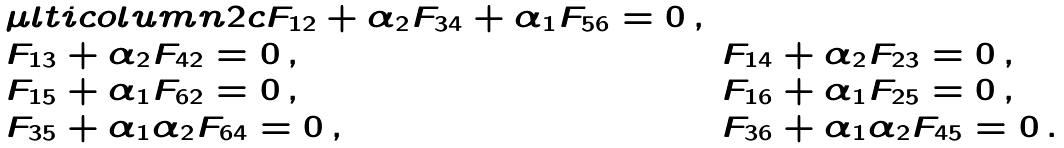Convert formula to latex. <formula><loc_0><loc_0><loc_500><loc_500>\begin{array} { l l } \mu l t i c o l u m n { 2 } { c } { F _ { 1 2 } + \alpha _ { 2 } F _ { 3 4 } + \alpha _ { 1 } F _ { 5 6 } = 0 \, , } \\ F _ { 1 3 } + \alpha _ { 2 } F _ { 4 2 } = 0 \, , & F _ { 1 4 } + \alpha _ { 2 } F _ { 2 3 } = 0 \, , \\ F _ { 1 5 } + \alpha _ { 1 } F _ { 6 2 } = 0 \, , & F _ { 1 6 } + \alpha _ { 1 } F _ { 2 5 } = 0 \, , \\ F _ { 3 5 } + \alpha _ { 1 } \alpha _ { 2 } F _ { 6 4 } = 0 \, , & F _ { 3 6 } + \alpha _ { 1 } \alpha _ { 2 } F _ { 4 5 } = 0 \, . \end{array}</formula> 